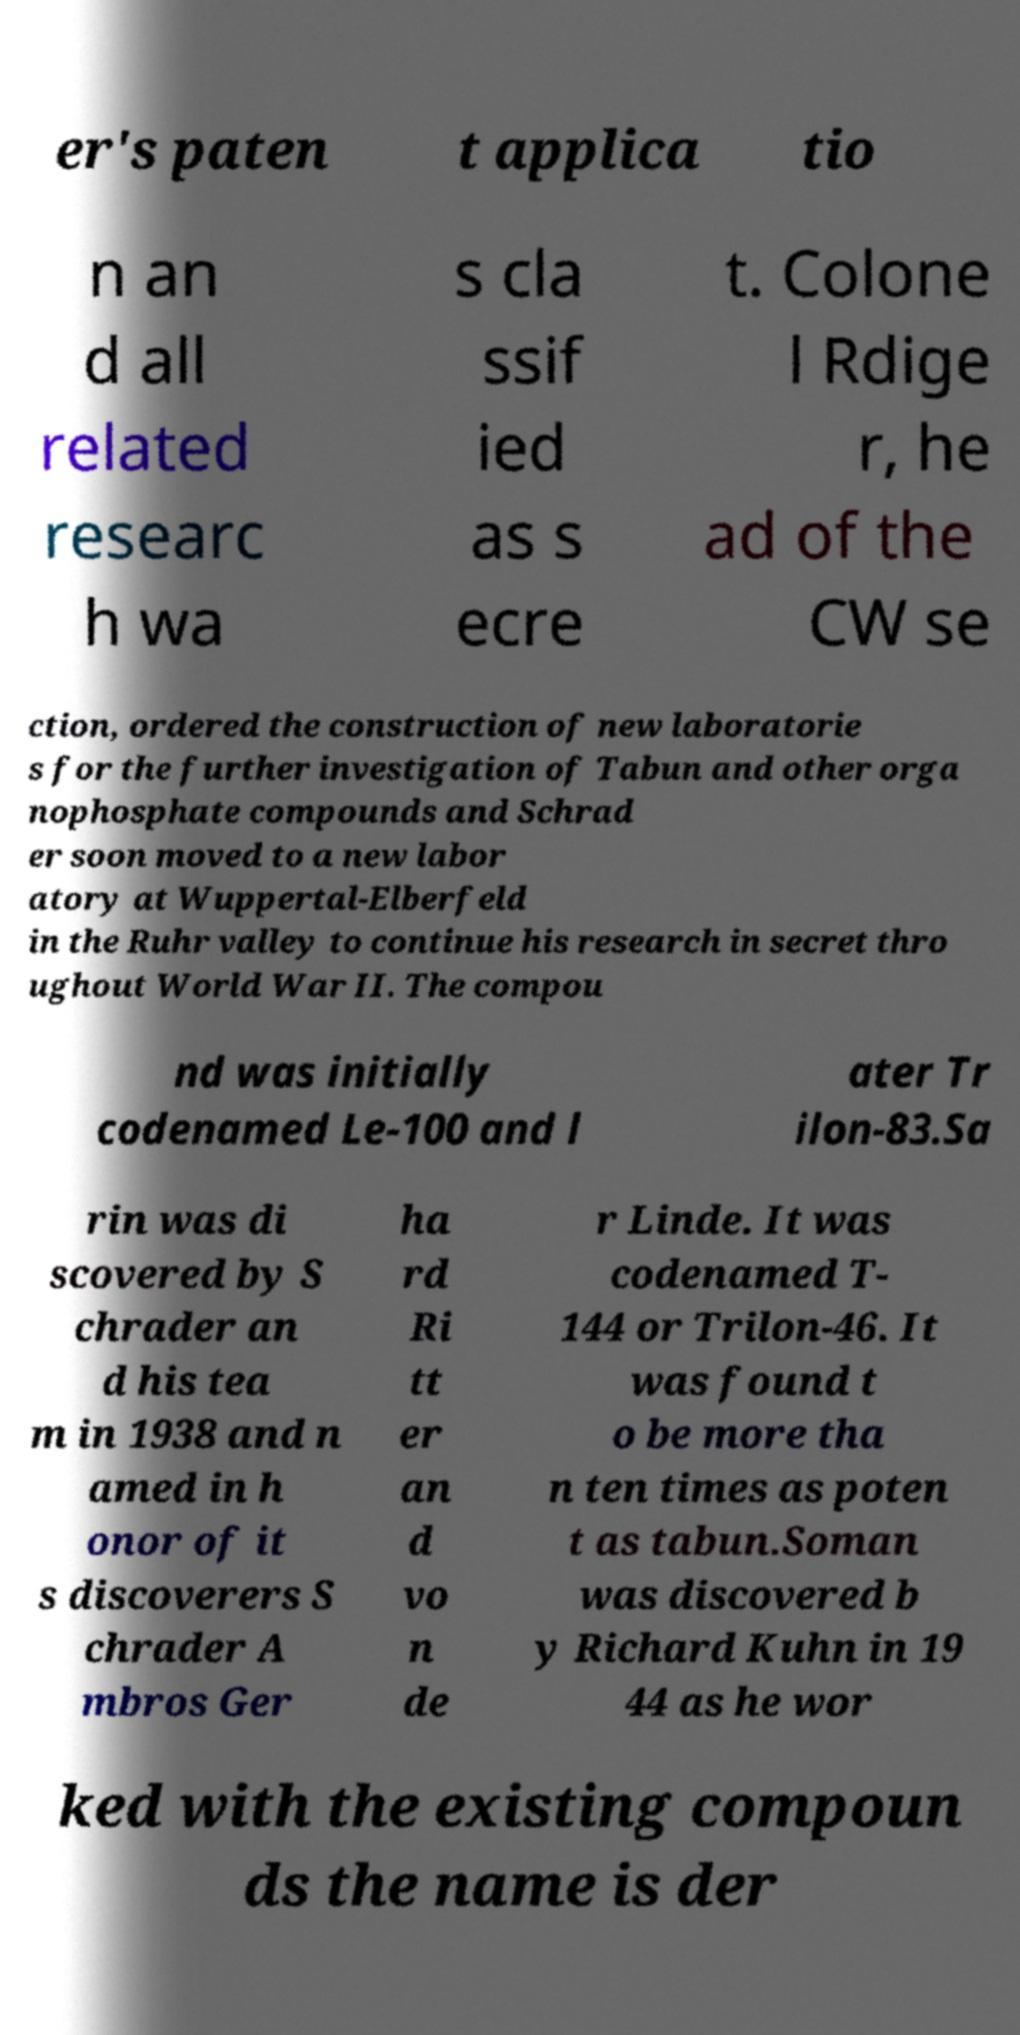There's text embedded in this image that I need extracted. Can you transcribe it verbatim? er's paten t applica tio n an d all related researc h wa s cla ssif ied as s ecre t. Colone l Rdige r, he ad of the CW se ction, ordered the construction of new laboratorie s for the further investigation of Tabun and other orga nophosphate compounds and Schrad er soon moved to a new labor atory at Wuppertal-Elberfeld in the Ruhr valley to continue his research in secret thro ughout World War II. The compou nd was initially codenamed Le-100 and l ater Tr ilon-83.Sa rin was di scovered by S chrader an d his tea m in 1938 and n amed in h onor of it s discoverers S chrader A mbros Ger ha rd Ri tt er an d vo n de r Linde. It was codenamed T- 144 or Trilon-46. It was found t o be more tha n ten times as poten t as tabun.Soman was discovered b y Richard Kuhn in 19 44 as he wor ked with the existing compoun ds the name is der 